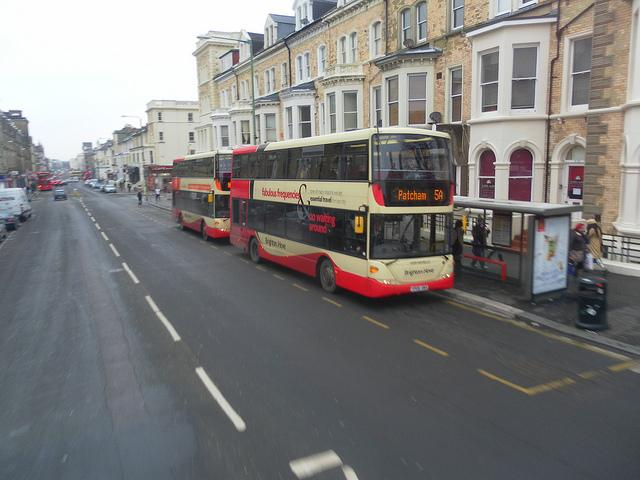When was the double-decker bus invented? Please explain your reasoning. 1906. It first came out in that year. 